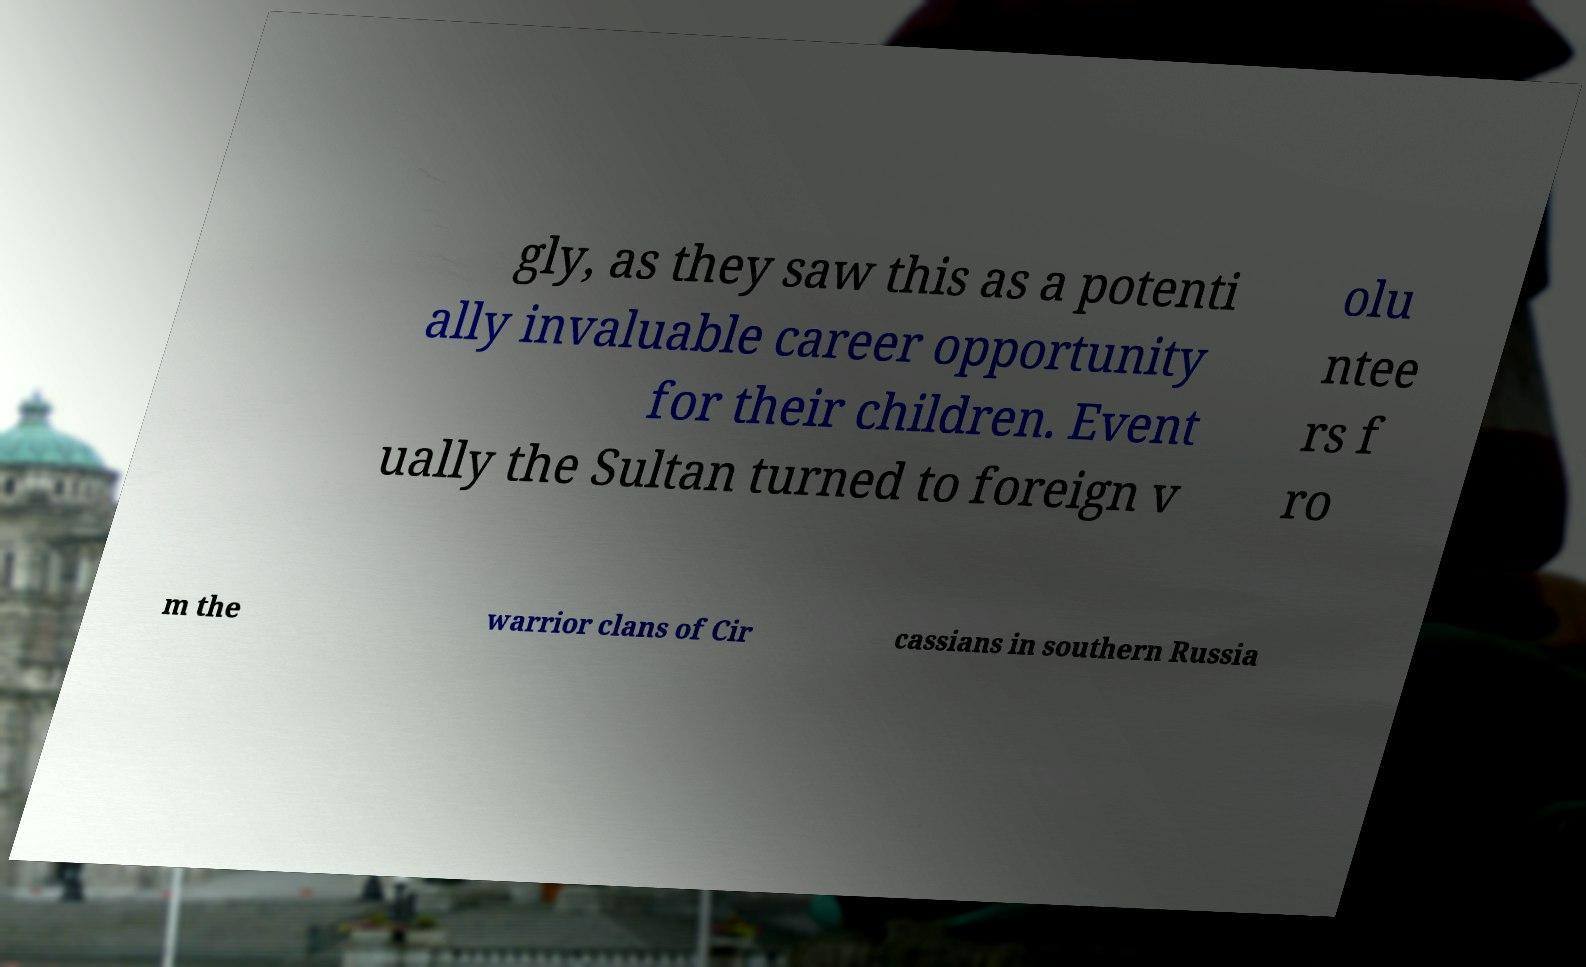Please identify and transcribe the text found in this image. gly, as they saw this as a potenti ally invaluable career opportunity for their children. Event ually the Sultan turned to foreign v olu ntee rs f ro m the warrior clans of Cir cassians in southern Russia 